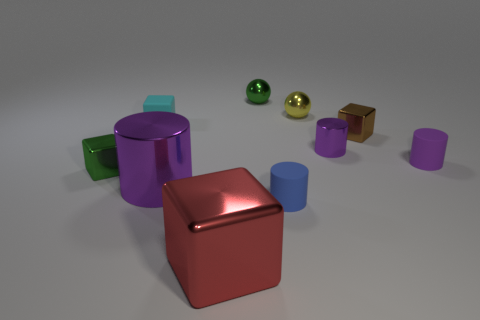Subtract all tiny metal cylinders. How many cylinders are left? 3 Subtract all gray blocks. How many purple cylinders are left? 3 Subtract all yellow balls. How many balls are left? 1 Subtract 2 blocks. How many blocks are left? 2 Subtract all balls. How many objects are left? 8 Subtract 0 blue balls. How many objects are left? 10 Subtract all blue balls. Subtract all purple cubes. How many balls are left? 2 Subtract all tiny shiny spheres. Subtract all brown objects. How many objects are left? 7 Add 2 tiny brown cubes. How many tiny brown cubes are left? 3 Add 5 purple shiny blocks. How many purple shiny blocks exist? 5 